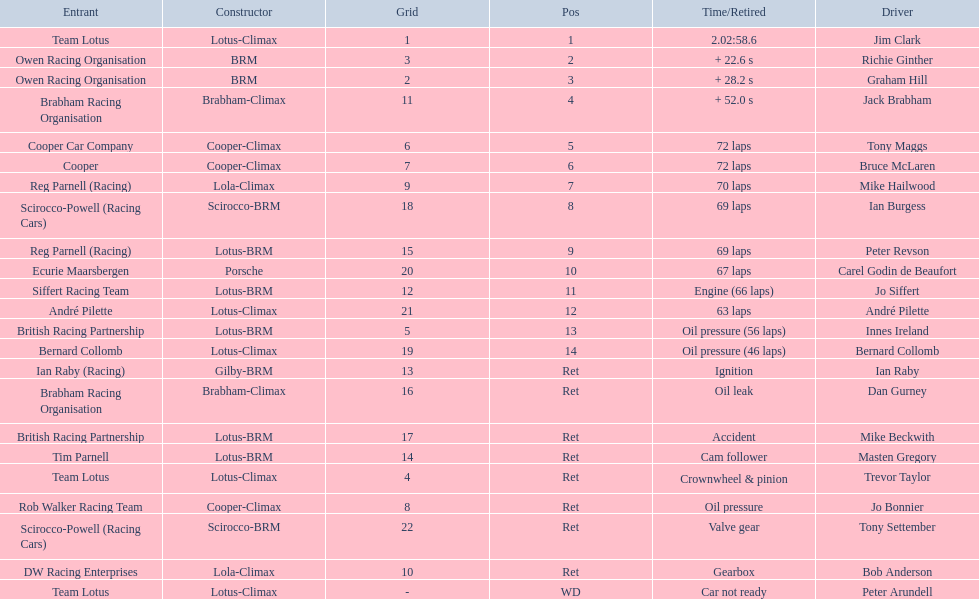What are the listed driver names? Jim Clark, Richie Ginther, Graham Hill, Jack Brabham, Tony Maggs, Bruce McLaren, Mike Hailwood, Ian Burgess, Peter Revson, Carel Godin de Beaufort, Jo Siffert, André Pilette, Innes Ireland, Bernard Collomb, Ian Raby, Dan Gurney, Mike Beckwith, Masten Gregory, Trevor Taylor, Jo Bonnier, Tony Settember, Bob Anderson, Peter Arundell. Which are tony maggs and jo siffert? Tony Maggs, Jo Siffert. What are their corresponding finishing places? 5, 11. Whose is better? Tony Maggs. 